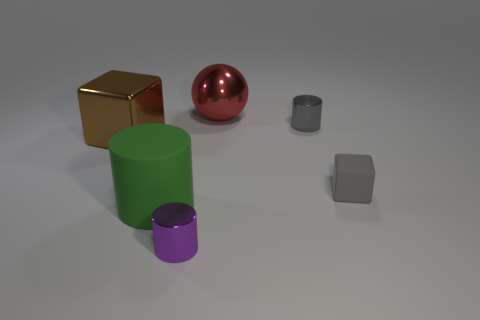What size is the other matte thing that is the same shape as the big brown object? Among the objects presented, the smaller grey cube has a matte finish and is the same shape as the bigger brown cube. This smaller cube is noticeably smaller in size compared to its larger counterpart. 